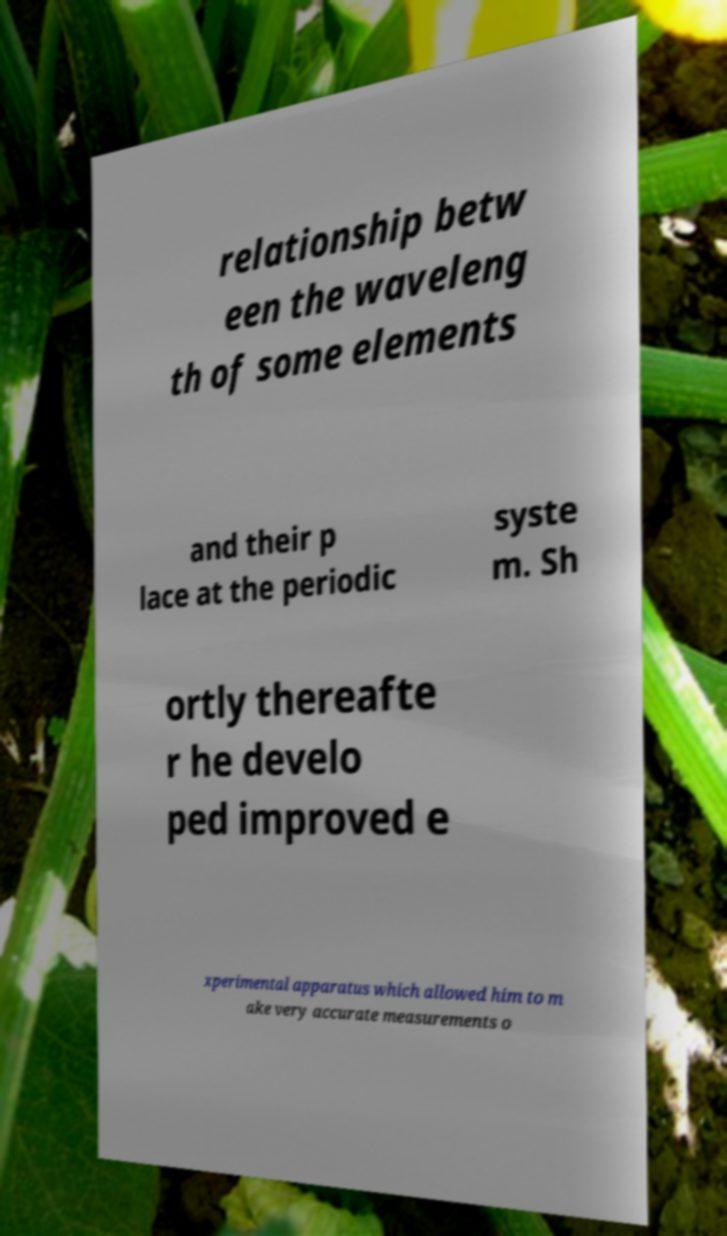Please identify and transcribe the text found in this image. relationship betw een the waveleng th of some elements and their p lace at the periodic syste m. Sh ortly thereafte r he develo ped improved e xperimental apparatus which allowed him to m ake very accurate measurements o 